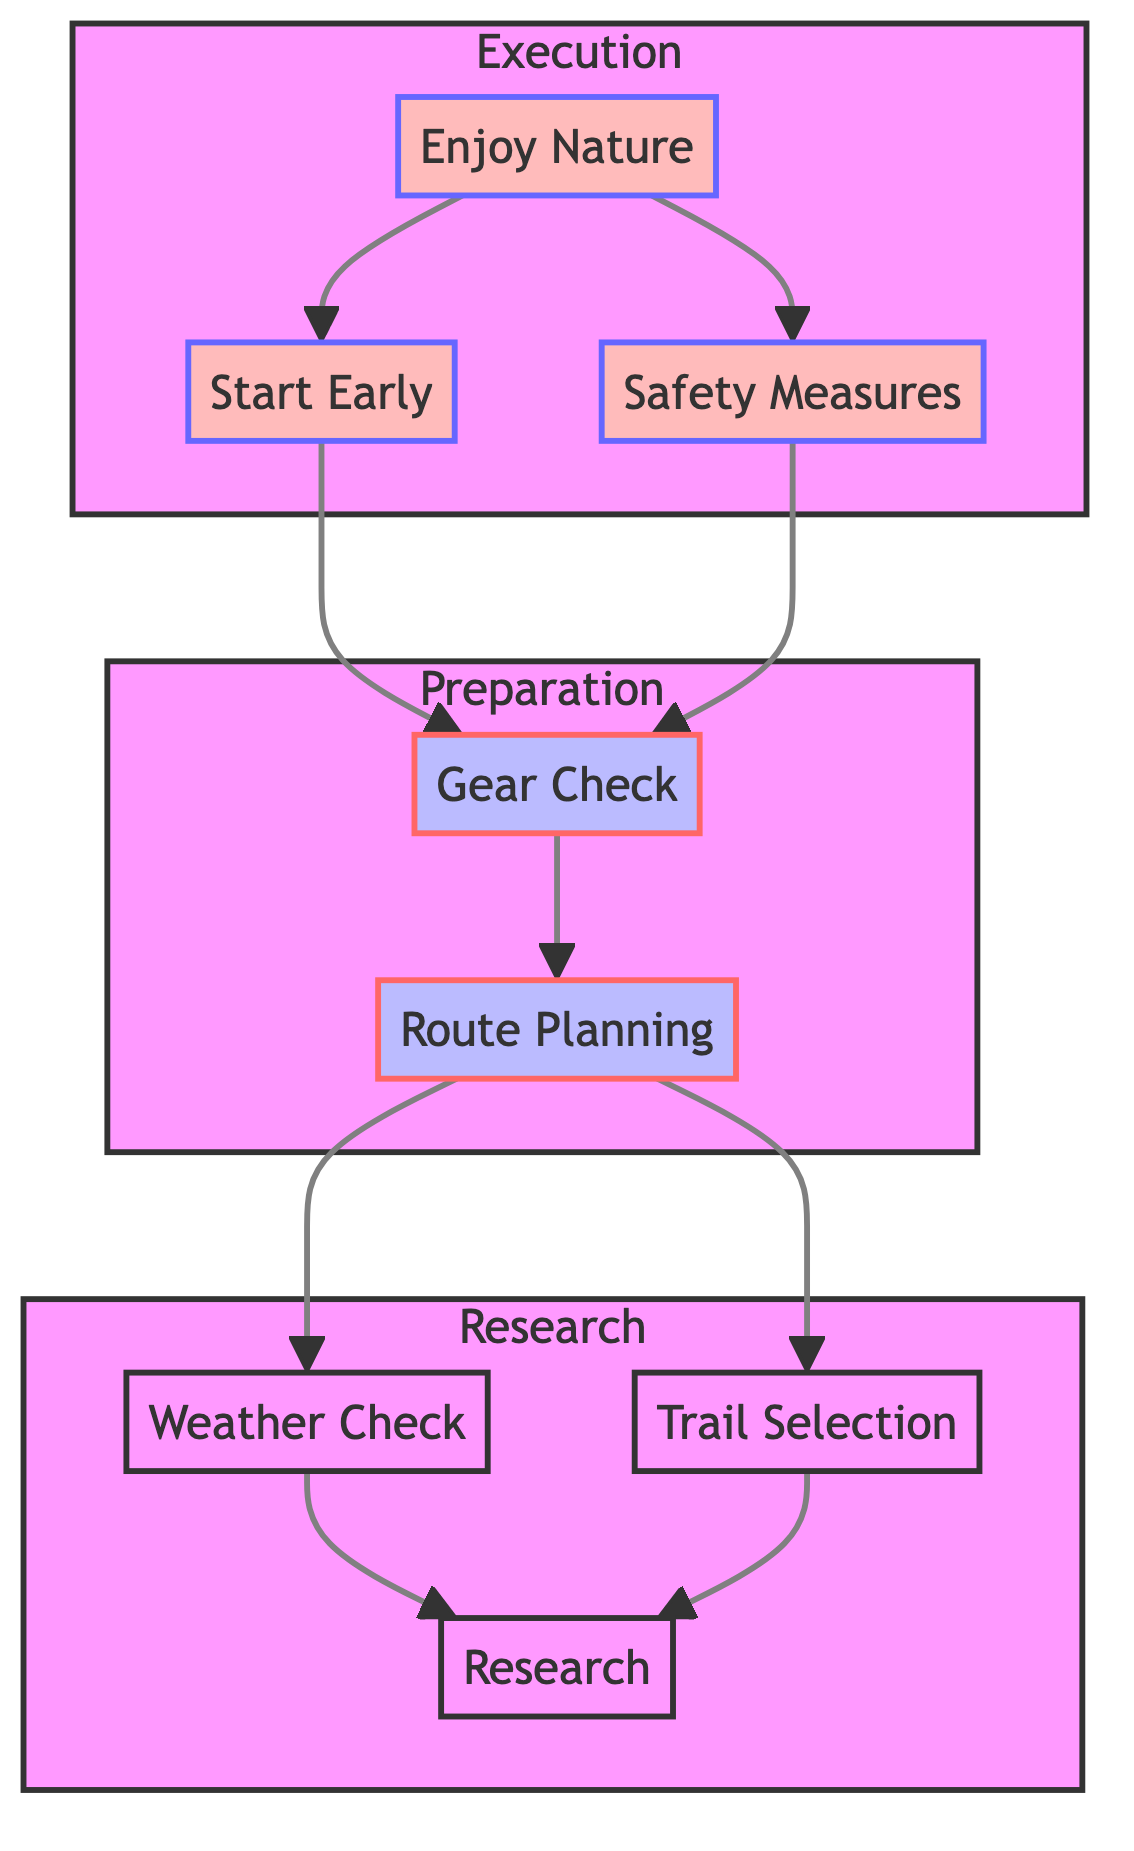What's the top node in the flowchart? The top node in the flowchart represents the ultimate goal of the day hike, which is to enjoy nature. This can be identified as the node that doesn't have any nodes above it and is the starting point for execution steps leading up to it.
Answer: Enjoy Nature How many main sections are there in the flowchart? The flowchart is divided into three main sections: Research, Preparation, and Execution. These sections group related tasks and actions which can be counted by observing the grouped activities or subgraphs.
Answer: 3 What steps follow after Gear Check? After the Gear Check step, the next step is Route Planning. This follows directly as a subsequent activity in the preparation phase, leading towards execution of the hike.
Answer: Route Planning What are two actions under Safety Measures? The actions listed under Safety Measures include informing a friend or family member, and carrying a first-aid kit. These are specifically mentioned as part of the safety protocols to follow during the execution phase.
Answer: Inform a Friend or Family Member, Carry a First-aid Kit Which node connects Preparation to Execution? The Gear Check node acts as the connection between the Preparation phase and the Execution phase, as both the Start Early and Safety Measures nodes depend on it for successful execution of the hike.
Answer: Gear Check What is an action associated with Start Early? One of the actions associated with Start Early is to avoid midday heat. This is depicted as a specific activity that directly supports the principle of starting early during the execution of a hike.
Answer: Avoid Midday Heat What are the two resources under Find Trails Online? The resources listed under Find Trails Online are AllTrails and Hiking Project. These are helpful websites identified in the Research phase for selecting trails to consider for the hike.
Answer: AllTrails, Hiking Project How does Weather Check relate to Trail Selection? Weather Check is a preparative step that informs trail selection; if the weather is unfavorable, certain trails might be deemed unsuitable. This relationship shows the need to assess conditions before selecting a trail to hike.
Answer: Affects Trail Selection What is the flow direction of the chart? The flow direction of the chart is from bottom to top. Each section ascends from actions taken to starting the hike, culminating in the overall goal, indicating a sequential progression in planning and execution.
Answer: Bottom to Top 